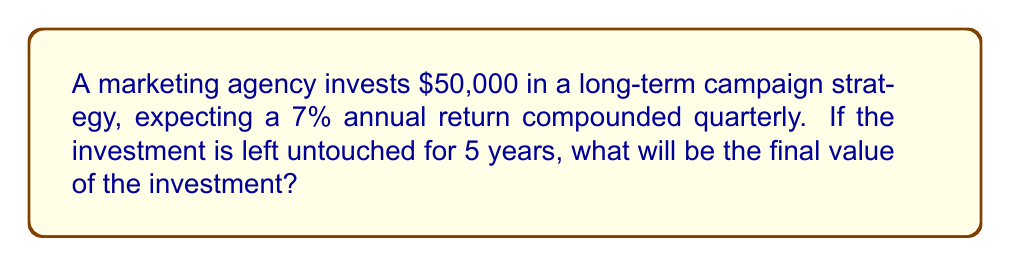Show me your answer to this math problem. To solve this problem, we'll use the compound interest formula:

$$A = P(1 + \frac{r}{n})^{nt}$$

Where:
$A$ = final amount
$P$ = principal (initial investment)
$r$ = annual interest rate (as a decimal)
$n$ = number of times interest is compounded per year
$t$ = number of years

Given:
$P = \$50,000$
$r = 0.07$ (7% expressed as a decimal)
$n = 4$ (compounded quarterly)
$t = 5$ years

Let's substitute these values into the formula:

$$A = 50000(1 + \frac{0.07}{4})^{4(5)}$$

$$A = 50000(1 + 0.0175)^{20}$$

$$A = 50000(1.0175)^{20}$$

Using a calculator:

$$A = 50000 * 1.4185856$$

$$A = 70929.28$$

Therefore, the final value of the investment after 5 years will be $70,929.28.
Answer: $70,929.28 